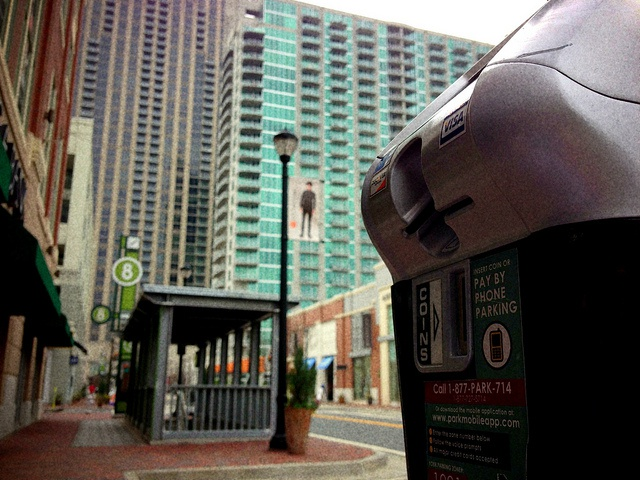Describe the objects in this image and their specific colors. I can see parking meter in black, gray, darkgray, and lightgray tones and people in black, gray, beige, darkgray, and tan tones in this image. 